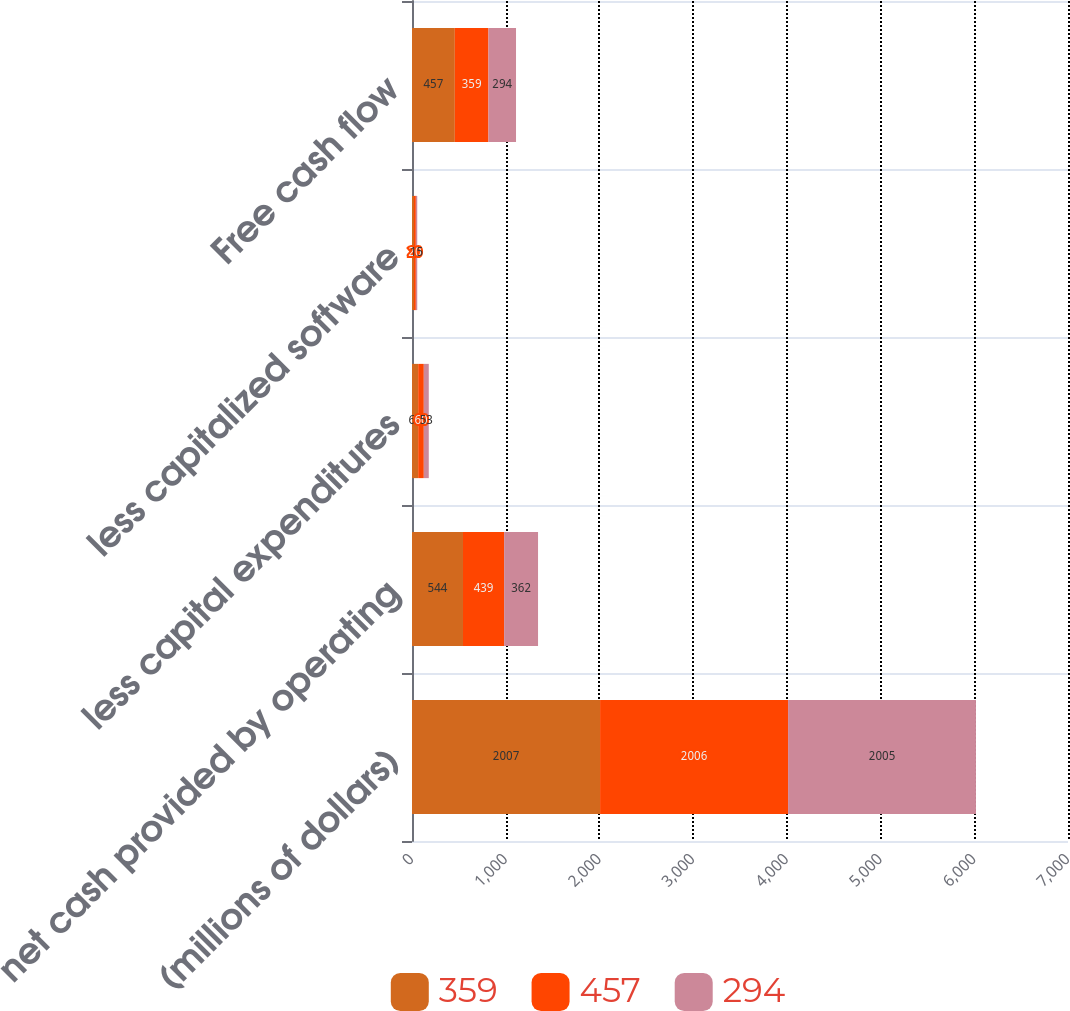<chart> <loc_0><loc_0><loc_500><loc_500><stacked_bar_chart><ecel><fcel>(millions of dollars)<fcel>net cash provided by operating<fcel>less capital expenditures<fcel>less capitalized software<fcel>Free cash flow<nl><fcel>359<fcel>2007<fcel>544<fcel>66<fcel>21<fcel>457<nl><fcel>457<fcel>2006<fcel>439<fcel>60<fcel>20<fcel>359<nl><fcel>294<fcel>2005<fcel>362<fcel>53<fcel>15<fcel>294<nl></chart> 